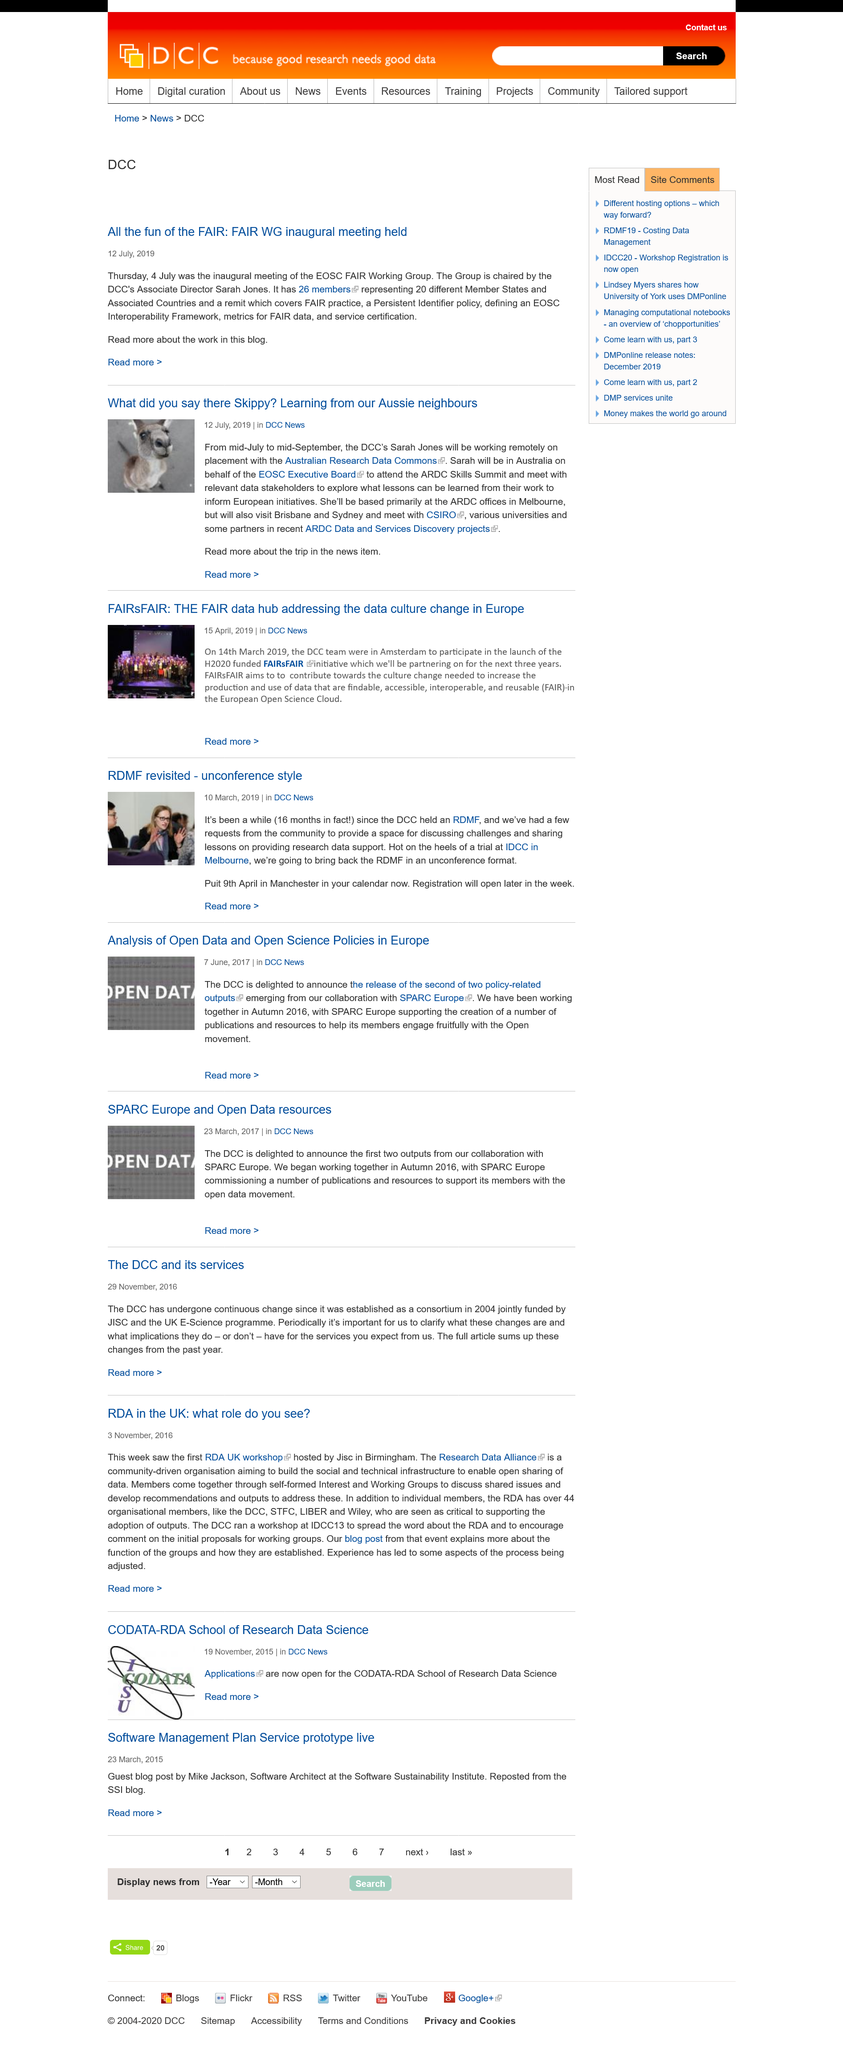List a handful of essential elements in this visual. The EOSC FAIR Working Group held its inaugural meeting on Thursday, 4 July. Sarah will be representing the EOSC Executive Board in Australia. The second article was published on July 12, 2019. 